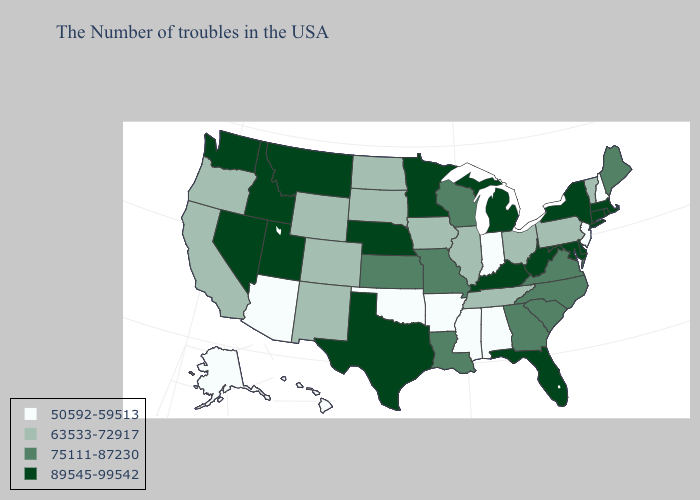Does the map have missing data?
Give a very brief answer. No. Name the states that have a value in the range 75111-87230?
Be succinct. Maine, Virginia, North Carolina, South Carolina, Georgia, Wisconsin, Louisiana, Missouri, Kansas. Which states hav the highest value in the South?
Give a very brief answer. Delaware, Maryland, West Virginia, Florida, Kentucky, Texas. What is the value of Pennsylvania?
Concise answer only. 63533-72917. What is the lowest value in the Northeast?
Short answer required. 50592-59513. Among the states that border Pennsylvania , does New Jersey have the lowest value?
Quick response, please. Yes. What is the value of Delaware?
Quick response, please. 89545-99542. How many symbols are there in the legend?
Answer briefly. 4. Which states have the lowest value in the West?
Answer briefly. Arizona, Alaska, Hawaii. What is the value of Arizona?
Keep it brief. 50592-59513. Which states have the lowest value in the Northeast?
Answer briefly. New Hampshire, New Jersey. Name the states that have a value in the range 75111-87230?
Answer briefly. Maine, Virginia, North Carolina, South Carolina, Georgia, Wisconsin, Louisiana, Missouri, Kansas. Is the legend a continuous bar?
Be succinct. No. What is the value of Colorado?
Write a very short answer. 63533-72917. 